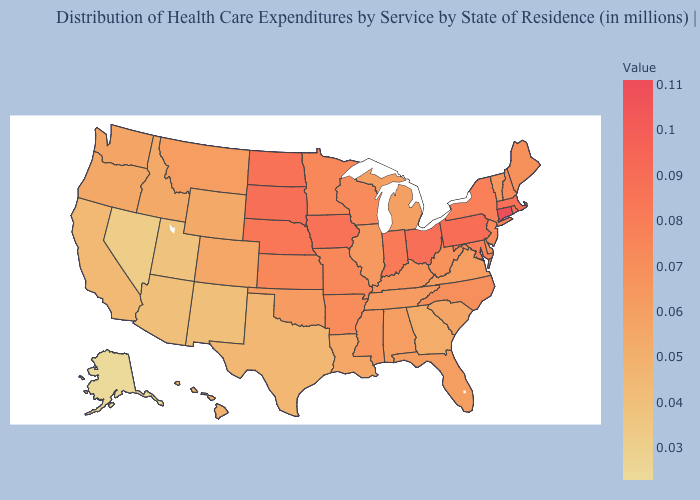Which states have the highest value in the USA?
Keep it brief. Connecticut. Among the states that border Louisiana , which have the lowest value?
Write a very short answer. Texas. Does Alaska have the lowest value in the West?
Quick response, please. Yes. Does South Carolina have the lowest value in the South?
Be succinct. No. Does West Virginia have a higher value than Ohio?
Write a very short answer. No. Which states have the highest value in the USA?
Keep it brief. Connecticut. 